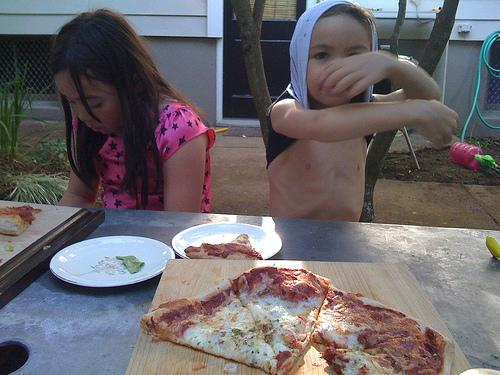Question: who are in the photo?
Choices:
A. Cats.
B. Man.
C. Kids.
D. Family.
Answer with the letter. Answer: C Question: what are the kids eating?
Choices:
A. Ice cream.
B. Pizza.
C. Donuts.
D. Tacos.
Answer with the letter. Answer: B Question: where was the photo taken?
Choices:
A. In the gym.
B. In the living room.
C. In the bedroom.
D. In a backyard.
Answer with the letter. Answer: D 